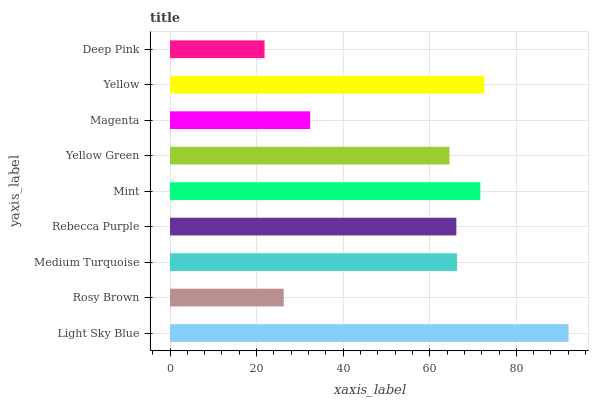Is Deep Pink the minimum?
Answer yes or no. Yes. Is Light Sky Blue the maximum?
Answer yes or no. Yes. Is Rosy Brown the minimum?
Answer yes or no. No. Is Rosy Brown the maximum?
Answer yes or no. No. Is Light Sky Blue greater than Rosy Brown?
Answer yes or no. Yes. Is Rosy Brown less than Light Sky Blue?
Answer yes or no. Yes. Is Rosy Brown greater than Light Sky Blue?
Answer yes or no. No. Is Light Sky Blue less than Rosy Brown?
Answer yes or no. No. Is Rebecca Purple the high median?
Answer yes or no. Yes. Is Rebecca Purple the low median?
Answer yes or no. Yes. Is Yellow the high median?
Answer yes or no. No. Is Yellow Green the low median?
Answer yes or no. No. 